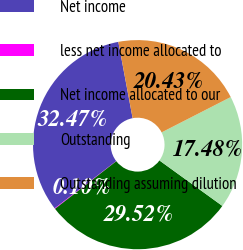<chart> <loc_0><loc_0><loc_500><loc_500><pie_chart><fcel>Net income<fcel>less net income allocated to<fcel>Net income allocated to our<fcel>Outstanding<fcel>Outstanding assuming dilution<nl><fcel>32.47%<fcel>0.1%<fcel>29.52%<fcel>17.48%<fcel>20.43%<nl></chart> 